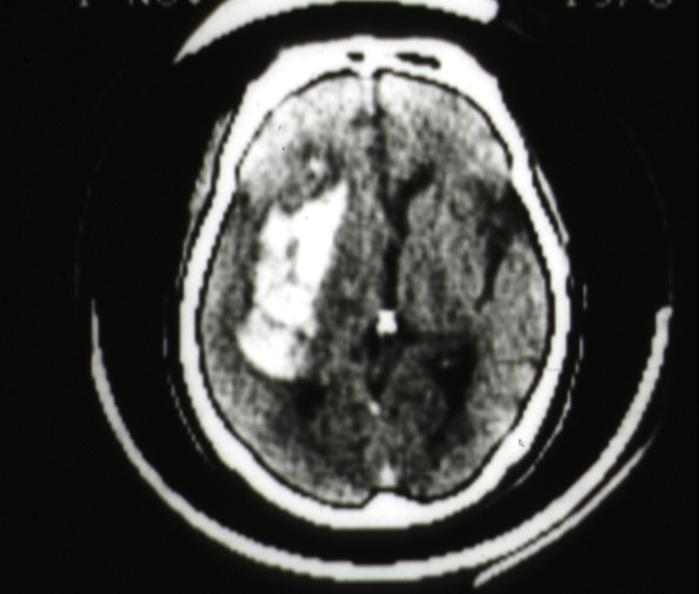what does this image show?
Answer the question using a single word or phrase. Cat scan hemorrhage in putamen area 